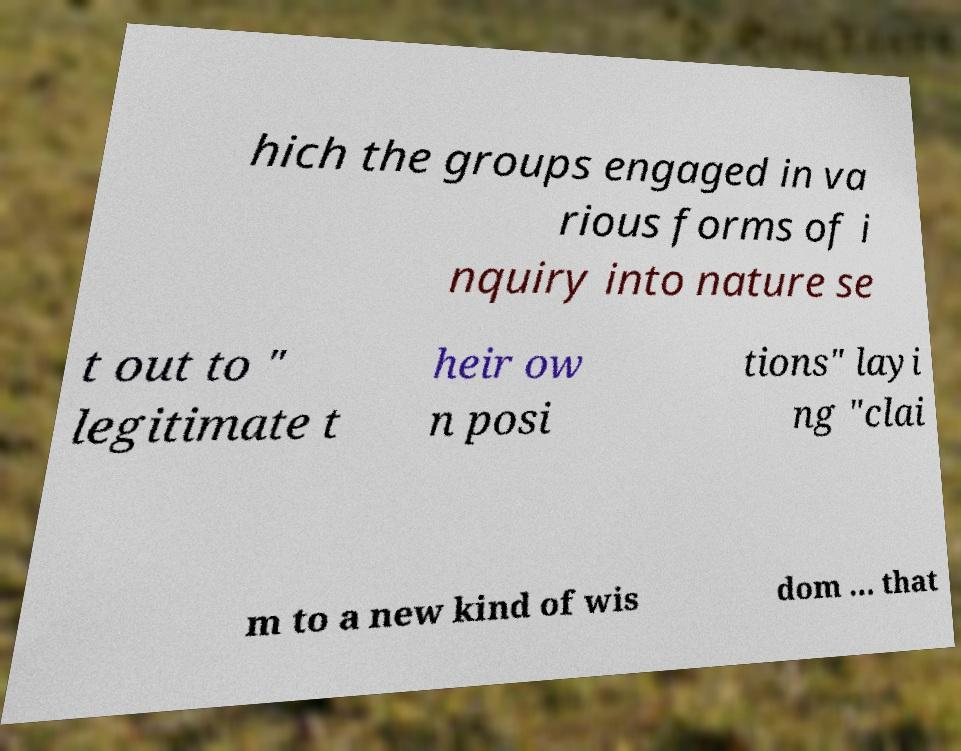There's text embedded in this image that I need extracted. Can you transcribe it verbatim? hich the groups engaged in va rious forms of i nquiry into nature se t out to " legitimate t heir ow n posi tions" layi ng "clai m to a new kind of wis dom ... that 